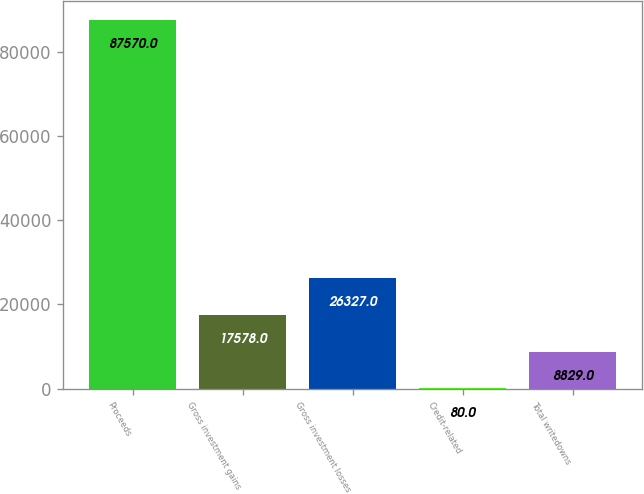Convert chart to OTSL. <chart><loc_0><loc_0><loc_500><loc_500><bar_chart><fcel>Proceeds<fcel>Gross investment gains<fcel>Gross investment losses<fcel>Credit-related<fcel>Total writedowns<nl><fcel>87570<fcel>17578<fcel>26327<fcel>80<fcel>8829<nl></chart> 